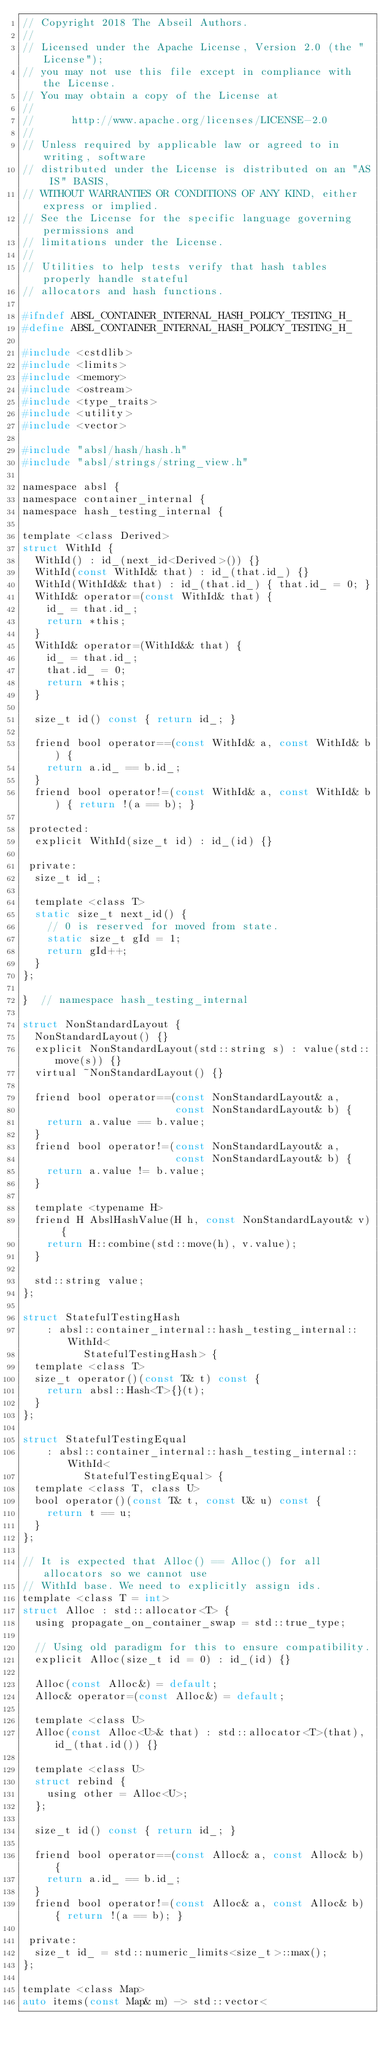<code> <loc_0><loc_0><loc_500><loc_500><_C_>// Copyright 2018 The Abseil Authors.
//
// Licensed under the Apache License, Version 2.0 (the "License");
// you may not use this file except in compliance with the License.
// You may obtain a copy of the License at
//
//      http://www.apache.org/licenses/LICENSE-2.0
//
// Unless required by applicable law or agreed to in writing, software
// distributed under the License is distributed on an "AS IS" BASIS,
// WITHOUT WARRANTIES OR CONDITIONS OF ANY KIND, either express or implied.
// See the License for the specific language governing permissions and
// limitations under the License.
//
// Utilities to help tests verify that hash tables properly handle stateful
// allocators and hash functions.

#ifndef ABSL_CONTAINER_INTERNAL_HASH_POLICY_TESTING_H_
#define ABSL_CONTAINER_INTERNAL_HASH_POLICY_TESTING_H_

#include <cstdlib>
#include <limits>
#include <memory>
#include <ostream>
#include <type_traits>
#include <utility>
#include <vector>

#include "absl/hash/hash.h"
#include "absl/strings/string_view.h"

namespace absl {
namespace container_internal {
namespace hash_testing_internal {

template <class Derived>
struct WithId {
  WithId() : id_(next_id<Derived>()) {}
  WithId(const WithId& that) : id_(that.id_) {}
  WithId(WithId&& that) : id_(that.id_) { that.id_ = 0; }
  WithId& operator=(const WithId& that) {
    id_ = that.id_;
    return *this;
  }
  WithId& operator=(WithId&& that) {
    id_ = that.id_;
    that.id_ = 0;
    return *this;
  }

  size_t id() const { return id_; }

  friend bool operator==(const WithId& a, const WithId& b) {
    return a.id_ == b.id_;
  }
  friend bool operator!=(const WithId& a, const WithId& b) { return !(a == b); }

 protected:
  explicit WithId(size_t id) : id_(id) {}

 private:
  size_t id_;

  template <class T>
  static size_t next_id() {
    // 0 is reserved for moved from state.
    static size_t gId = 1;
    return gId++;
  }
};

}  // namespace hash_testing_internal

struct NonStandardLayout {
  NonStandardLayout() {}
  explicit NonStandardLayout(std::string s) : value(std::move(s)) {}
  virtual ~NonStandardLayout() {}

  friend bool operator==(const NonStandardLayout& a,
                         const NonStandardLayout& b) {
    return a.value == b.value;
  }
  friend bool operator!=(const NonStandardLayout& a,
                         const NonStandardLayout& b) {
    return a.value != b.value;
  }

  template <typename H>
  friend H AbslHashValue(H h, const NonStandardLayout& v) {
    return H::combine(std::move(h), v.value);
  }

  std::string value;
};

struct StatefulTestingHash
    : absl::container_internal::hash_testing_internal::WithId<
          StatefulTestingHash> {
  template <class T>
  size_t operator()(const T& t) const {
    return absl::Hash<T>{}(t);
  }
};

struct StatefulTestingEqual
    : absl::container_internal::hash_testing_internal::WithId<
          StatefulTestingEqual> {
  template <class T, class U>
  bool operator()(const T& t, const U& u) const {
    return t == u;
  }
};

// It is expected that Alloc() == Alloc() for all allocators so we cannot use
// WithId base. We need to explicitly assign ids.
template <class T = int>
struct Alloc : std::allocator<T> {
  using propagate_on_container_swap = std::true_type;

  // Using old paradigm for this to ensure compatibility.
  explicit Alloc(size_t id = 0) : id_(id) {}

  Alloc(const Alloc&) = default;
  Alloc& operator=(const Alloc&) = default;

  template <class U>
  Alloc(const Alloc<U>& that) : std::allocator<T>(that), id_(that.id()) {}

  template <class U>
  struct rebind {
    using other = Alloc<U>;
  };

  size_t id() const { return id_; }

  friend bool operator==(const Alloc& a, const Alloc& b) {
    return a.id_ == b.id_;
  }
  friend bool operator!=(const Alloc& a, const Alloc& b) { return !(a == b); }

 private:
  size_t id_ = std::numeric_limits<size_t>::max();
};

template <class Map>
auto items(const Map& m) -> std::vector<</code> 